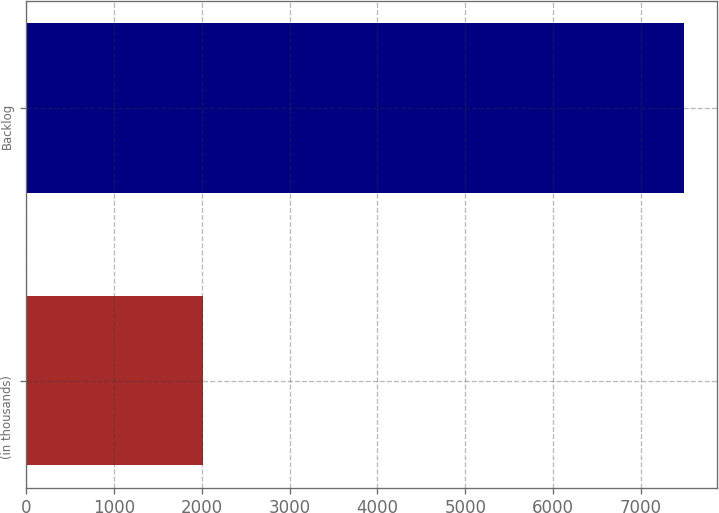Convert chart to OTSL. <chart><loc_0><loc_0><loc_500><loc_500><bar_chart><fcel>(in thousands)<fcel>Backlog<nl><fcel>2010<fcel>7492<nl></chart> 